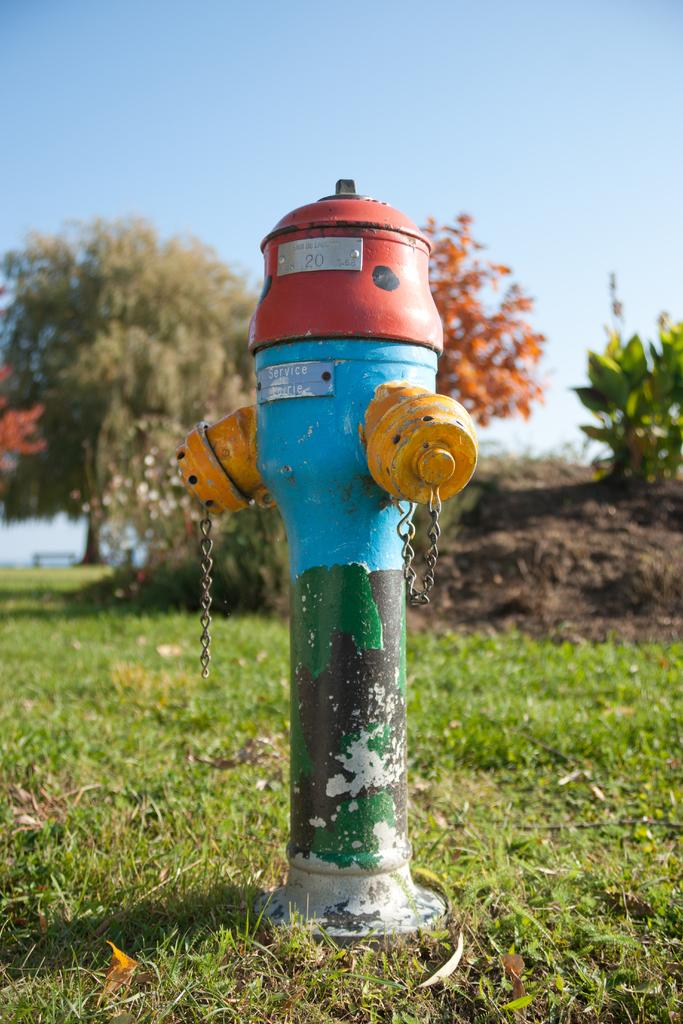<image>
Create a compact narrative representing the image presented. Fire hydrant number twenty has a red top with a silver tag on. 